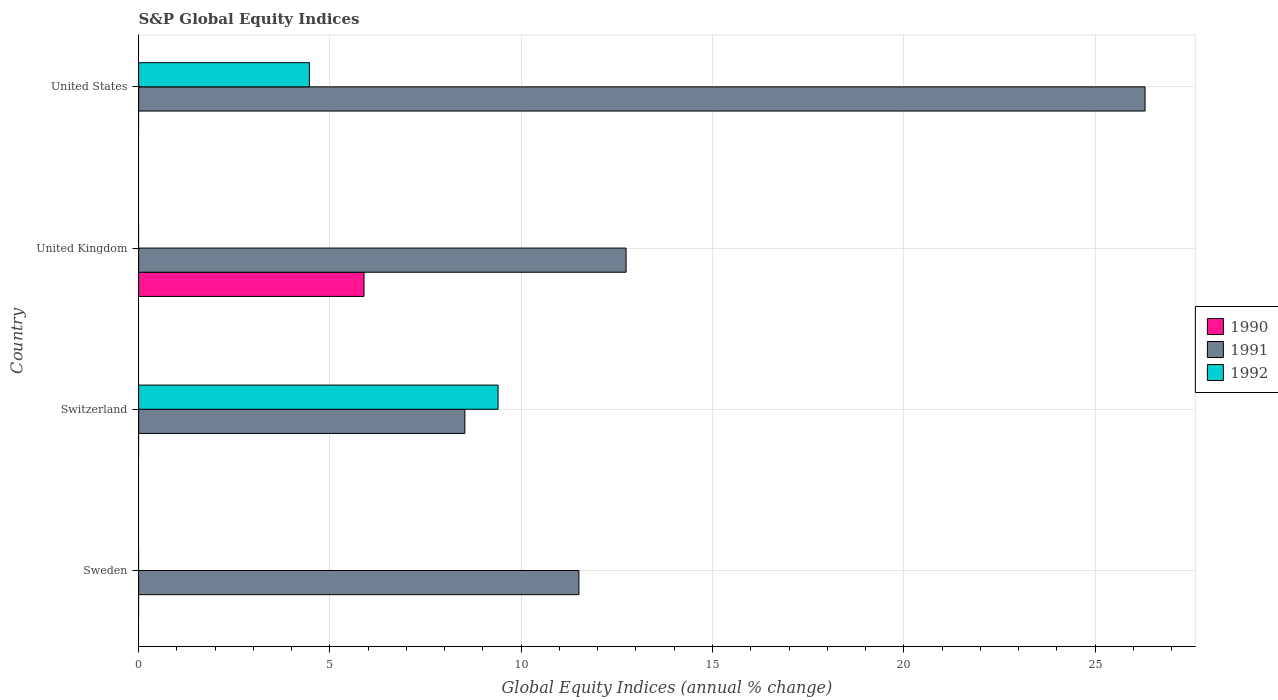Are the number of bars per tick equal to the number of legend labels?
Your answer should be compact. No. How many bars are there on the 1st tick from the top?
Give a very brief answer. 2. How many bars are there on the 1st tick from the bottom?
Offer a very short reply. 1. What is the label of the 1st group of bars from the top?
Provide a succinct answer. United States. Across all countries, what is the maximum global equity indices in 1991?
Give a very brief answer. 26.31. Across all countries, what is the minimum global equity indices in 1991?
Provide a succinct answer. 8.53. What is the total global equity indices in 1991 in the graph?
Provide a succinct answer. 59.08. What is the difference between the global equity indices in 1991 in Sweden and that in United States?
Your answer should be very brief. -14.8. What is the difference between the global equity indices in 1992 in United Kingdom and the global equity indices in 1990 in Switzerland?
Provide a short and direct response. 0. What is the average global equity indices in 1992 per country?
Offer a terse response. 3.46. What is the difference between the global equity indices in 1991 and global equity indices in 1992 in United States?
Offer a very short reply. 21.84. What is the ratio of the global equity indices in 1991 in Switzerland to that in United States?
Your answer should be very brief. 0.32. What is the difference between the highest and the second highest global equity indices in 1991?
Your answer should be compact. 13.57. What is the difference between the highest and the lowest global equity indices in 1992?
Your response must be concise. 9.4. Are all the bars in the graph horizontal?
Your answer should be very brief. Yes. What is the difference between two consecutive major ticks on the X-axis?
Offer a very short reply. 5. Where does the legend appear in the graph?
Your answer should be compact. Center right. How are the legend labels stacked?
Keep it short and to the point. Vertical. What is the title of the graph?
Offer a terse response. S&P Global Equity Indices. What is the label or title of the X-axis?
Offer a very short reply. Global Equity Indices (annual % change). What is the Global Equity Indices (annual % change) in 1991 in Sweden?
Your answer should be very brief. 11.51. What is the Global Equity Indices (annual % change) of 1992 in Sweden?
Provide a succinct answer. 0. What is the Global Equity Indices (annual % change) in 1990 in Switzerland?
Offer a very short reply. 0. What is the Global Equity Indices (annual % change) of 1991 in Switzerland?
Keep it short and to the point. 8.53. What is the Global Equity Indices (annual % change) in 1992 in Switzerland?
Give a very brief answer. 9.4. What is the Global Equity Indices (annual % change) in 1990 in United Kingdom?
Ensure brevity in your answer.  5.89. What is the Global Equity Indices (annual % change) of 1991 in United Kingdom?
Your response must be concise. 12.74. What is the Global Equity Indices (annual % change) in 1990 in United States?
Your answer should be very brief. 0. What is the Global Equity Indices (annual % change) in 1991 in United States?
Provide a succinct answer. 26.31. What is the Global Equity Indices (annual % change) of 1992 in United States?
Your answer should be very brief. 4.46. Across all countries, what is the maximum Global Equity Indices (annual % change) in 1990?
Ensure brevity in your answer.  5.89. Across all countries, what is the maximum Global Equity Indices (annual % change) in 1991?
Provide a succinct answer. 26.31. Across all countries, what is the maximum Global Equity Indices (annual % change) of 1992?
Provide a succinct answer. 9.4. Across all countries, what is the minimum Global Equity Indices (annual % change) of 1990?
Your answer should be compact. 0. Across all countries, what is the minimum Global Equity Indices (annual % change) in 1991?
Ensure brevity in your answer.  8.53. What is the total Global Equity Indices (annual % change) in 1990 in the graph?
Ensure brevity in your answer.  5.89. What is the total Global Equity Indices (annual % change) in 1991 in the graph?
Ensure brevity in your answer.  59.08. What is the total Global Equity Indices (annual % change) in 1992 in the graph?
Your response must be concise. 13.86. What is the difference between the Global Equity Indices (annual % change) of 1991 in Sweden and that in Switzerland?
Give a very brief answer. 2.98. What is the difference between the Global Equity Indices (annual % change) in 1991 in Sweden and that in United Kingdom?
Provide a succinct answer. -1.23. What is the difference between the Global Equity Indices (annual % change) of 1991 in Sweden and that in United States?
Make the answer very short. -14.8. What is the difference between the Global Equity Indices (annual % change) of 1991 in Switzerland and that in United Kingdom?
Give a very brief answer. -4.21. What is the difference between the Global Equity Indices (annual % change) in 1991 in Switzerland and that in United States?
Make the answer very short. -17.78. What is the difference between the Global Equity Indices (annual % change) of 1992 in Switzerland and that in United States?
Keep it short and to the point. 4.93. What is the difference between the Global Equity Indices (annual % change) in 1991 in United Kingdom and that in United States?
Provide a short and direct response. -13.57. What is the difference between the Global Equity Indices (annual % change) of 1991 in Sweden and the Global Equity Indices (annual % change) of 1992 in Switzerland?
Ensure brevity in your answer.  2.11. What is the difference between the Global Equity Indices (annual % change) of 1991 in Sweden and the Global Equity Indices (annual % change) of 1992 in United States?
Your answer should be very brief. 7.04. What is the difference between the Global Equity Indices (annual % change) in 1991 in Switzerland and the Global Equity Indices (annual % change) in 1992 in United States?
Provide a short and direct response. 4.06. What is the difference between the Global Equity Indices (annual % change) in 1990 in United Kingdom and the Global Equity Indices (annual % change) in 1991 in United States?
Your answer should be compact. -20.42. What is the difference between the Global Equity Indices (annual % change) in 1990 in United Kingdom and the Global Equity Indices (annual % change) in 1992 in United States?
Keep it short and to the point. 1.43. What is the difference between the Global Equity Indices (annual % change) of 1991 in United Kingdom and the Global Equity Indices (annual % change) of 1992 in United States?
Give a very brief answer. 8.28. What is the average Global Equity Indices (annual % change) of 1990 per country?
Give a very brief answer. 1.47. What is the average Global Equity Indices (annual % change) in 1991 per country?
Offer a very short reply. 14.77. What is the average Global Equity Indices (annual % change) of 1992 per country?
Provide a succinct answer. 3.46. What is the difference between the Global Equity Indices (annual % change) in 1991 and Global Equity Indices (annual % change) in 1992 in Switzerland?
Give a very brief answer. -0.87. What is the difference between the Global Equity Indices (annual % change) in 1990 and Global Equity Indices (annual % change) in 1991 in United Kingdom?
Ensure brevity in your answer.  -6.85. What is the difference between the Global Equity Indices (annual % change) of 1991 and Global Equity Indices (annual % change) of 1992 in United States?
Offer a very short reply. 21.84. What is the ratio of the Global Equity Indices (annual % change) of 1991 in Sweden to that in Switzerland?
Your answer should be compact. 1.35. What is the ratio of the Global Equity Indices (annual % change) of 1991 in Sweden to that in United Kingdom?
Make the answer very short. 0.9. What is the ratio of the Global Equity Indices (annual % change) in 1991 in Sweden to that in United States?
Your response must be concise. 0.44. What is the ratio of the Global Equity Indices (annual % change) in 1991 in Switzerland to that in United Kingdom?
Give a very brief answer. 0.67. What is the ratio of the Global Equity Indices (annual % change) in 1991 in Switzerland to that in United States?
Your answer should be very brief. 0.32. What is the ratio of the Global Equity Indices (annual % change) of 1992 in Switzerland to that in United States?
Your answer should be compact. 2.1. What is the ratio of the Global Equity Indices (annual % change) of 1991 in United Kingdom to that in United States?
Offer a terse response. 0.48. What is the difference between the highest and the second highest Global Equity Indices (annual % change) in 1991?
Provide a short and direct response. 13.57. What is the difference between the highest and the lowest Global Equity Indices (annual % change) of 1990?
Provide a short and direct response. 5.89. What is the difference between the highest and the lowest Global Equity Indices (annual % change) in 1991?
Make the answer very short. 17.78. What is the difference between the highest and the lowest Global Equity Indices (annual % change) in 1992?
Keep it short and to the point. 9.4. 